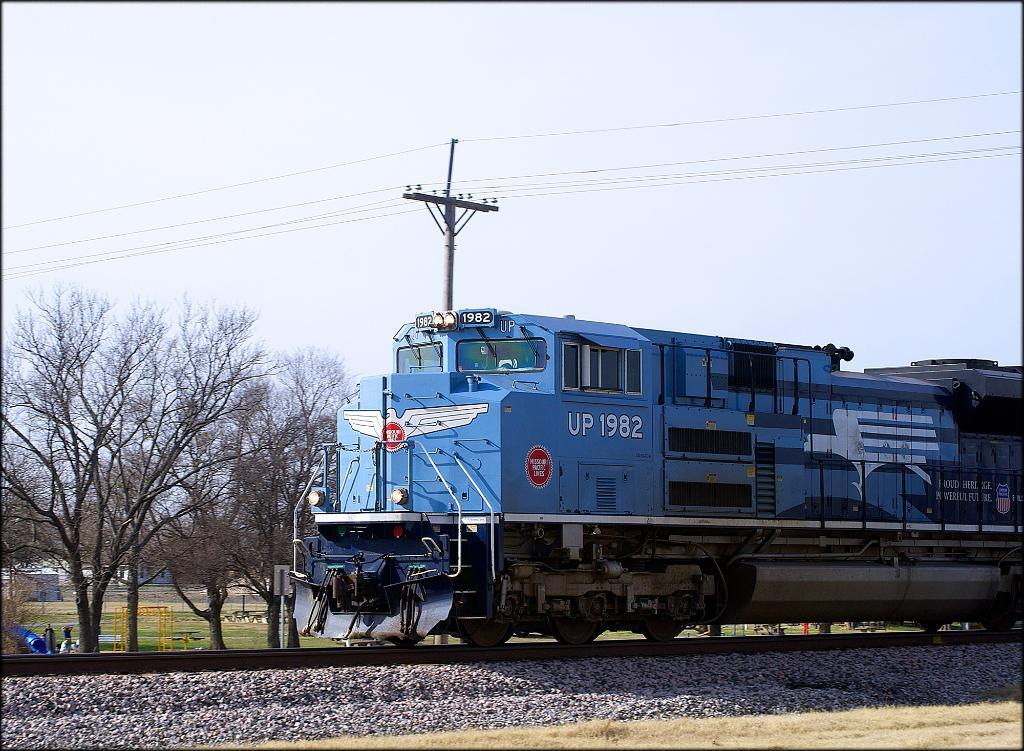<image>
Present a compact description of the photo's key features. A blue train which has UP 1982 on the side of it. 